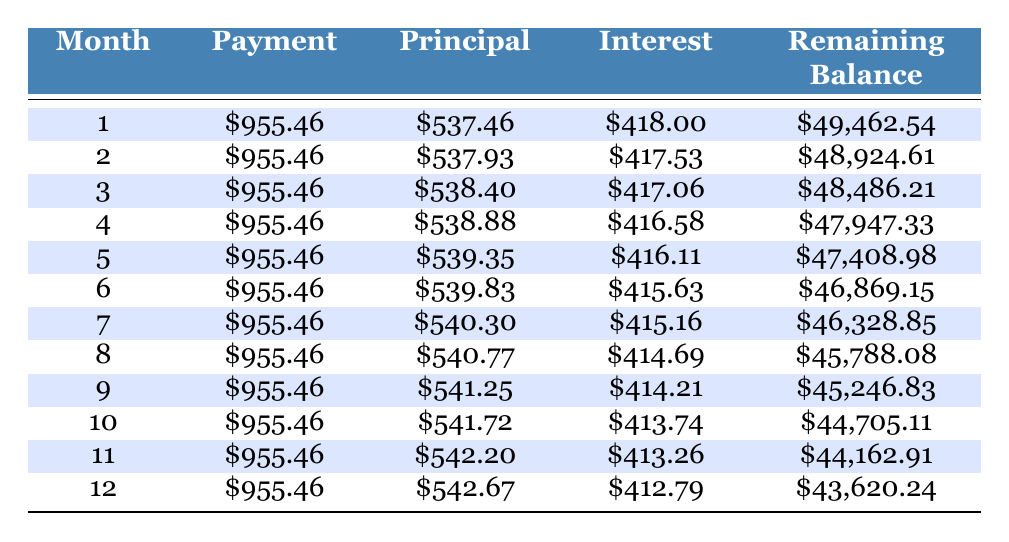What is the monthly payment amount? The table shows that the monthly payment is consistently listed as 955.46 in each month.
Answer: 955.46 How much principal is paid off in the first month? In the first month, the table indicates that the principal payment is 537.46.
Answer: 537.46 What is the interest amount for the second month? According to the table, the interest for the second month is listed as 417.53.
Answer: 417.53 What is the total principal paid over the first three months? To find the total principal for the first three months, we sum the principal amounts: 537.46 + 537.93 + 538.40 = 1613.79.
Answer: 1613.79 Is the interest payment in the third month higher than in the second month? The interest in the second month is 417.53 and in the third month it is 417.06; since 417.06 is less than 417.53, the answer is no.
Answer: No What is the remaining balance after 12 months? The remaining balance is given in the last row of the table, which shows it as 43,620.24 after 12 months.
Answer: 43,620.24 What is the difference in principal paid between the sixth and seventh months? From the table, we see the principal in the sixth month is 539.83, and in the seventh month, it is 540.30. The difference is 540.30 - 539.83 = 0.47.
Answer: 0.47 What is the average interest payment over the first 12 months? To find the average interest payment, we need to sum all the monthly interest amounts and divide by 12. Summing the displayed interest values yields approximately 5,015.74, so the average is approximately 5,015.74 / 12 = 417.98.
Answer: 417.98 In which month is the remaining balance below 45,000? The remaining balance is below 45,000 starting from month 10, as indicated by the balance being 44,705.11 then.
Answer: Month 10 